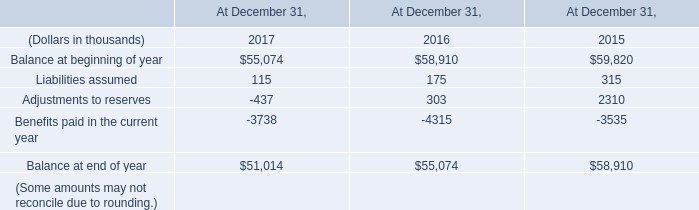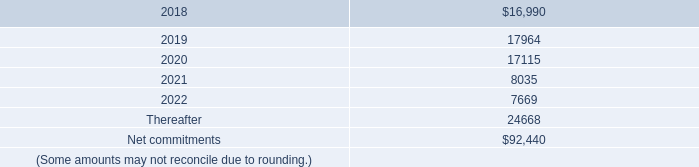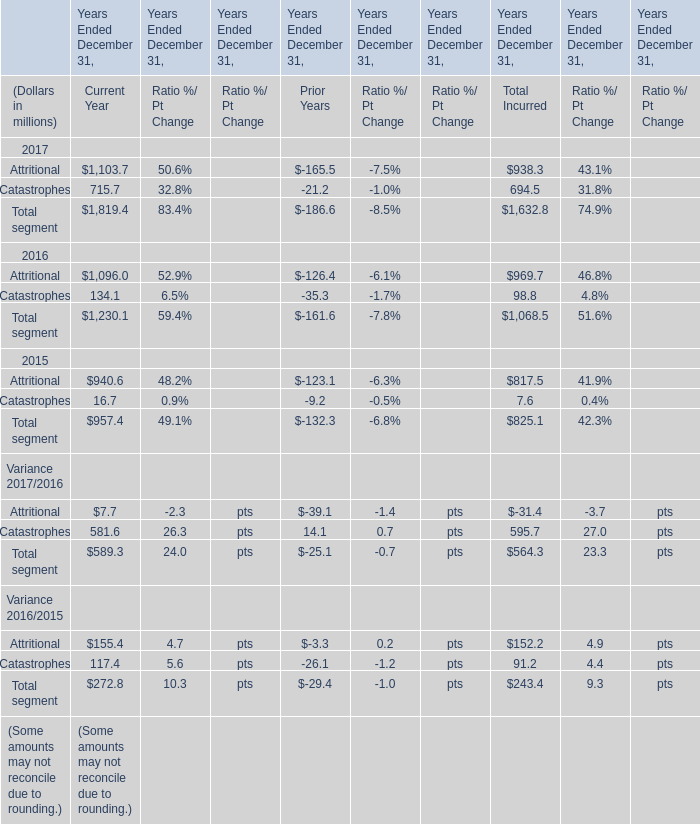The total amount of which section ranks first in 2017 for Current Year ? 
Answer: Total segment. 